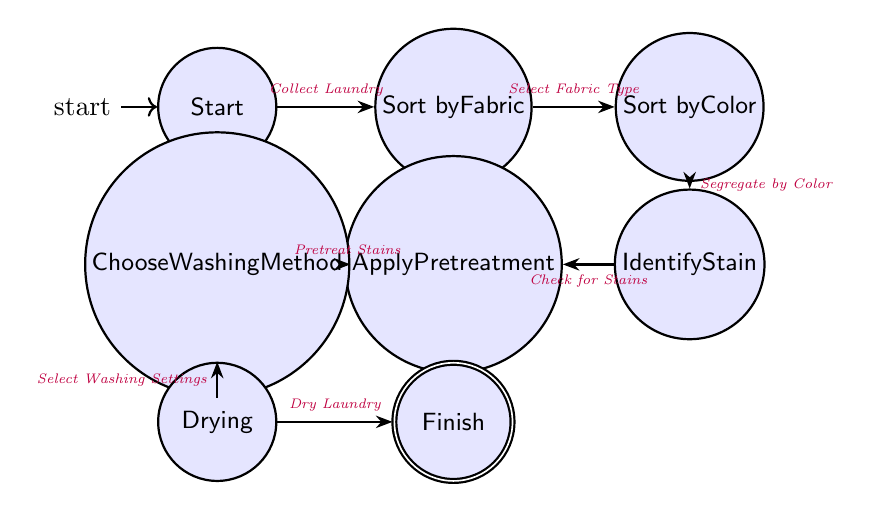What is the initial state of the diagram? The initial state is the first state in the diagram, which is labeled "Start". This is indicated by the arrow pointing towards it from nowhere, showing it is the starting point of the process.
Answer: Start How many states are there in total? By counting each unique labeled state in the diagram, there are a total of 8 states represented.
Answer: 8 What action leads from "Sort by Fabric" to "Sort by Color"? The transition from "Sort by Fabric" to "Sort by Color" is indicated by the action "Select Fabric Type", which defines the decision or step needed to move to the next state.
Answer: Select Fabric Type What is the final state called in the diagram? The final state, represented as the accepting state, is labeled "Finish", which signifies the completion of the laundry sorting process.
Answer: Finish Which state immediately follows "Identify Stain"? According to the transitions shown, the state that follows "Identify Stain" is "Apply Pretreatment", indicating the next action to address stains identified.
Answer: Apply Pretreatment What action is performed after "Drying"? The action that follows "Drying" is "Dry Laundry", completing the final step before reaching the end of the process.
Answer: Dry Laundry Which two states are connected by "Segregate by Color"? The states connected by "Segregate by Color" are "Sort by Color" and "Identify Stain", showing the flow from sorting by color to identifying any stains present.
Answer: Sort by Color, Identify Stain What is the relationship between "Apply Pretreatment" and "Choose Washing Method"? The relationship is that the action "Pretreat Stains" must occur in "Apply Pretreatment" before moving on to "Choose Washing Method", indicating a sequence in the stain removal process.
Answer: Pretreat Stains 